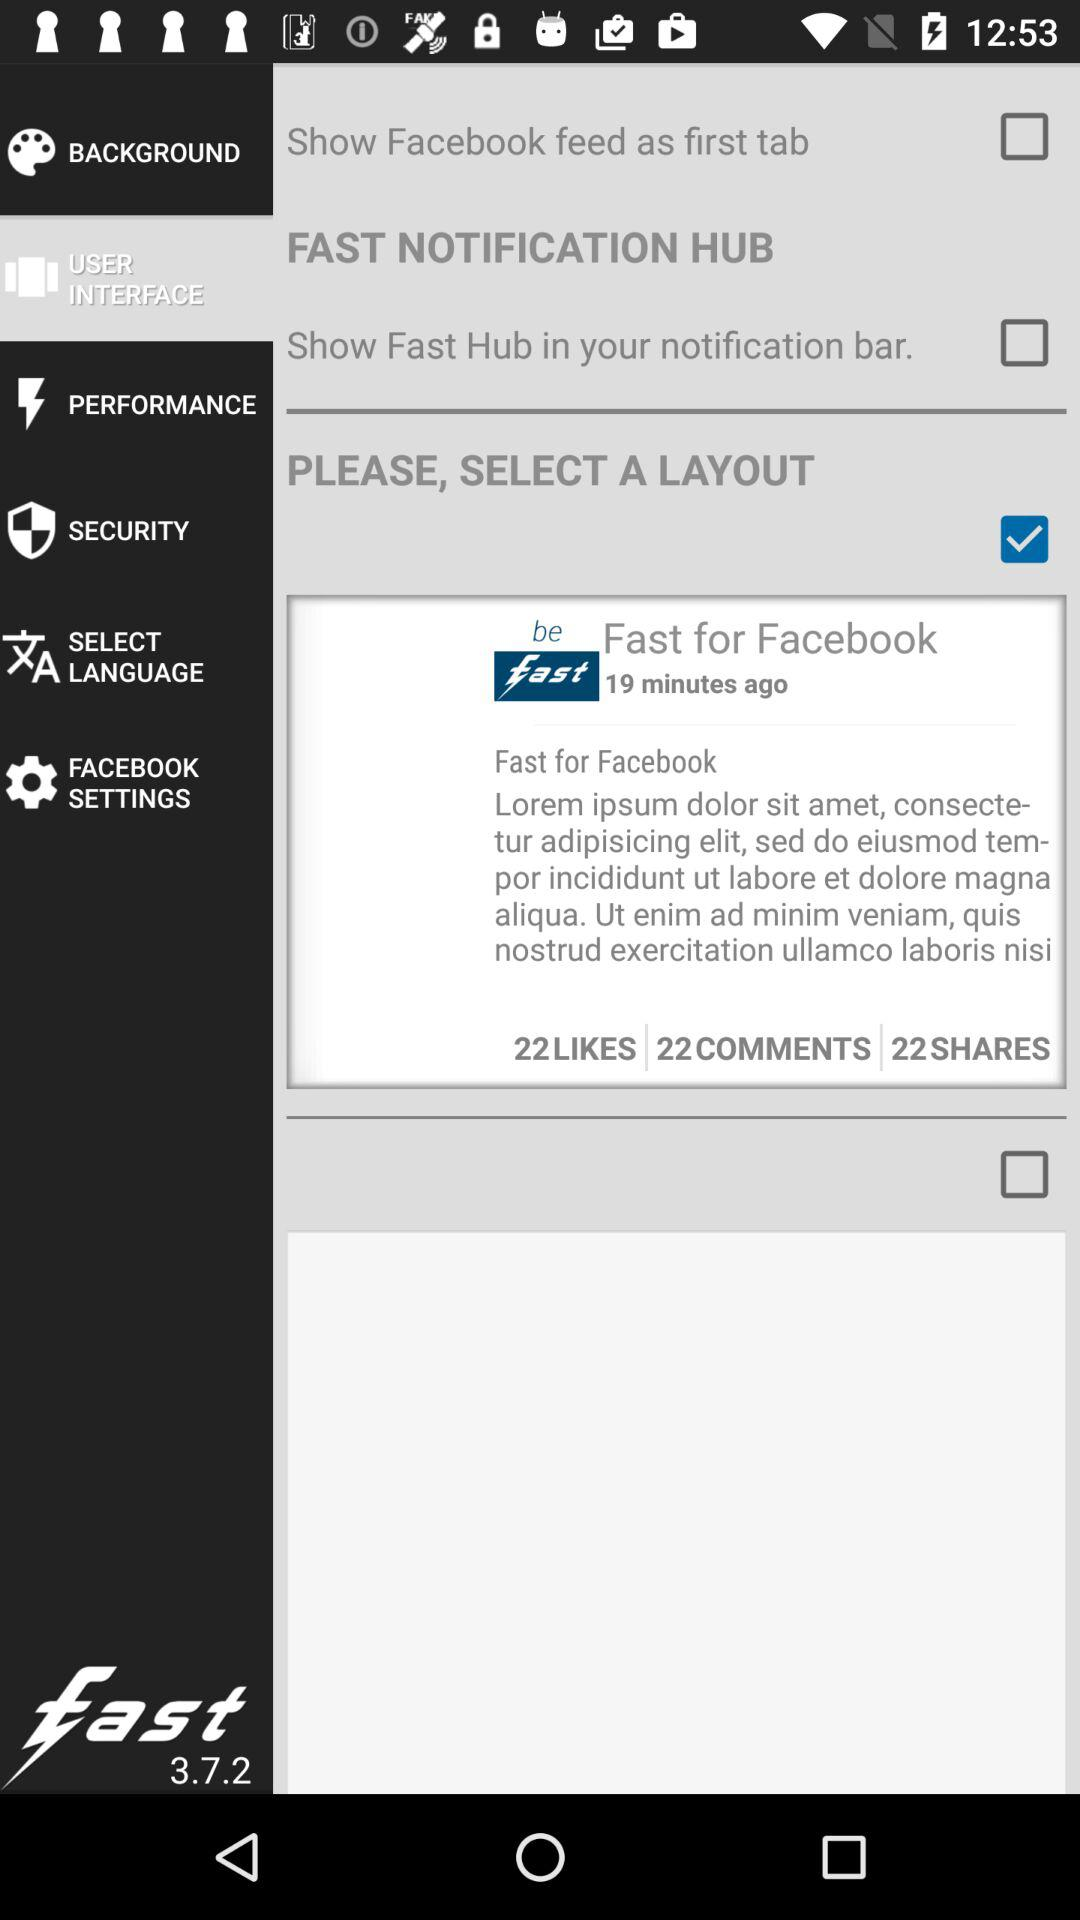What is the status of "PLEASE, SELECT A LAYOUT"? The status is "on". 